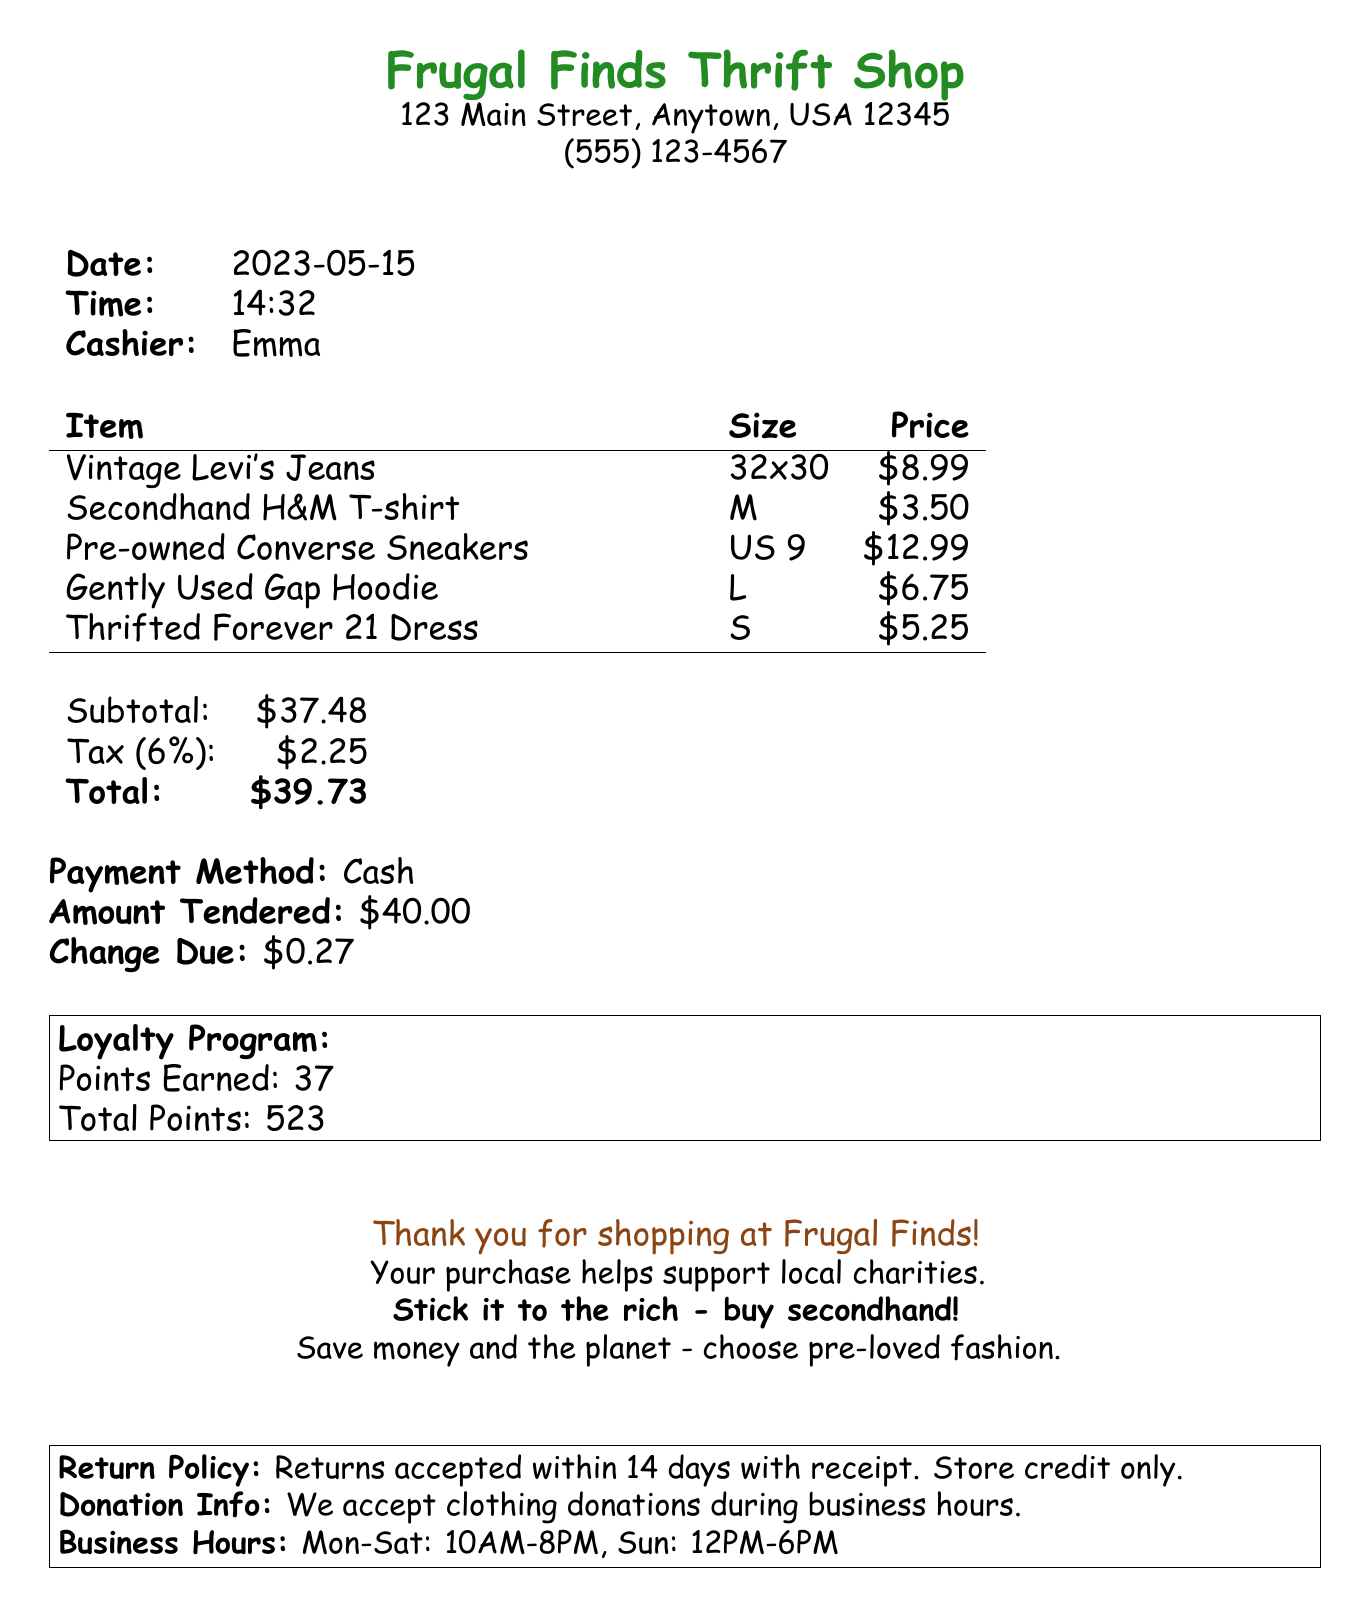What is the name of the thrift store? The name of the thrift store is found at the top of the document.
Answer: Frugal Finds Thrift Shop What is the date of purchase? The date of purchase is listed in the document.
Answer: 2023-05-15 Who was the cashier? The cashier's name is mentioned in the document.
Answer: Emma What is the total amount spent? The total amount is found in the summary table of the receipt.
Answer: 39.73 How many points were earned in the loyalty program? The points earned are stated in the loyalty program section.
Answer: 37 What is the size of the Vintage Levi's Jeans? The size is specified next to the item description in the items list.
Answer: 32x30 What is the return policy? The return policy is described at the bottom of the receipt.
Answer: Returns accepted within 14 days with receipt. Store credit only What payment method was used? The payment method is clearly stated in the document.
Answer: Cash What environmental message is included? The message is found in the footer messages section.
Answer: Save money and the planet - choose pre-loved fashion 